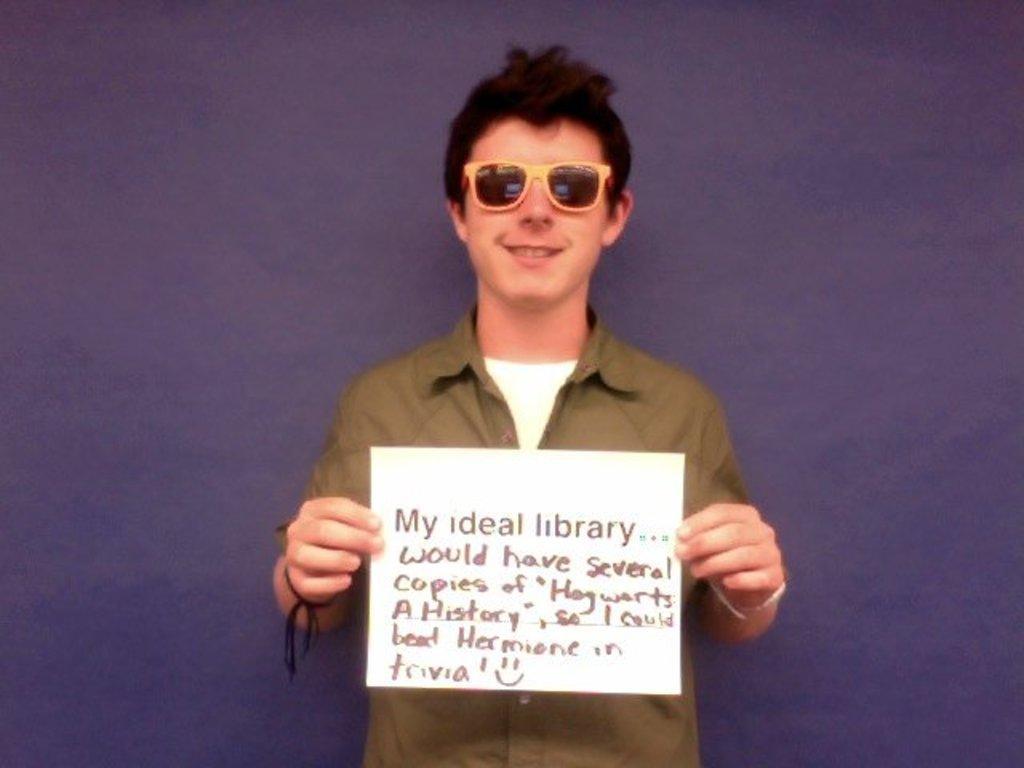Please provide a concise description of this image. In this image in the center there is one person who is standing and he is holding one paper, on the paper there is some text and in the background there is wall. 